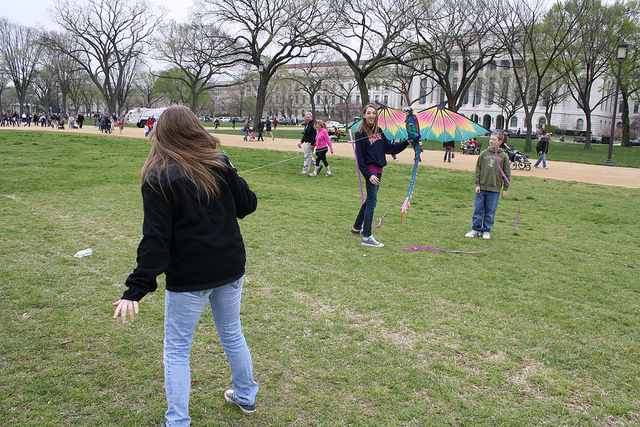This image appears to have been taken at a public place. Can you guess what event might be occurring here, based on the activities seen? Based on the open space, multiple people, and activities such as kite flying, this image seems to depict a leisurely day at a public park. It might be a spring or summer day where individuals, families, and friends come to enjoy the outdoors. There isn't a clear indication of a specific event, but the setting is conducive to casual recreation, picnics, or community gatherings. 